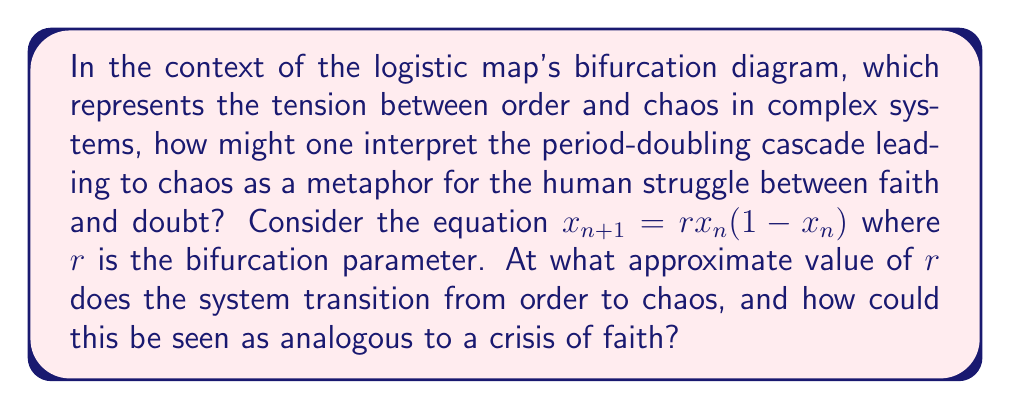Can you solve this math problem? To answer this question, we need to analyze the bifurcation diagram of the logistic map:

1) The logistic map is given by the equation $x_{n+1} = rx_n(1-x_n)$, where $r$ is the bifurcation parameter.

2) As $r$ increases from 0 to 4, we observe the following behavior:

   - For $0 < r < 1$, the population dies out (x converges to 0).
   - For $1 < r < 3$, the population converges to a single fixed point.
   - At $r = 3$, the first bifurcation occurs, and the system oscillates between two values.
   - As $r$ increases further, the system undergoes period-doubling bifurcations.
   - At approximately $r ≈ 3.57$, the period-doubling cascade ends, and chaos begins.

3) The transition to chaos at $r ≈ 3.57$ is known as the accumulation point of the period-doubling cascade.

4) From a theological perspective, this transition could be interpreted as follows:
   - The orderly region ($r < 3.57$) represents a state of strong, unwavering faith.
   - The period-doubling bifurcations represent increasing doubts and questions.
   - The transition to chaos ($r ≈ 3.57$) represents a crisis of faith, where certainty gives way to unpredictability and doubt.

5) The value $r ≈ 3.57$ is significant because it marks the boundary between predictable, ordered behavior and chaotic, unpredictable behavior. In the context of faith, this could represent the point at which doubts and questions overwhelm one's established beliefs, leading to a state of spiritual uncertainty or crisis.

6) It's worth noting that even in the chaotic regime, there are still "windows" of order, which could be seen as moments of clarity or renewed faith amidst doubt.
Answer: $r ≈ 3.57$, representing the transition from order to chaos, analogous to a crisis of faith. 